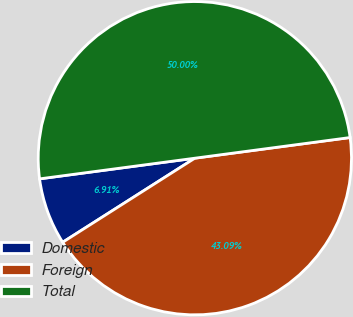Convert chart to OTSL. <chart><loc_0><loc_0><loc_500><loc_500><pie_chart><fcel>Domestic<fcel>Foreign<fcel>Total<nl><fcel>6.91%<fcel>43.09%<fcel>50.0%<nl></chart> 